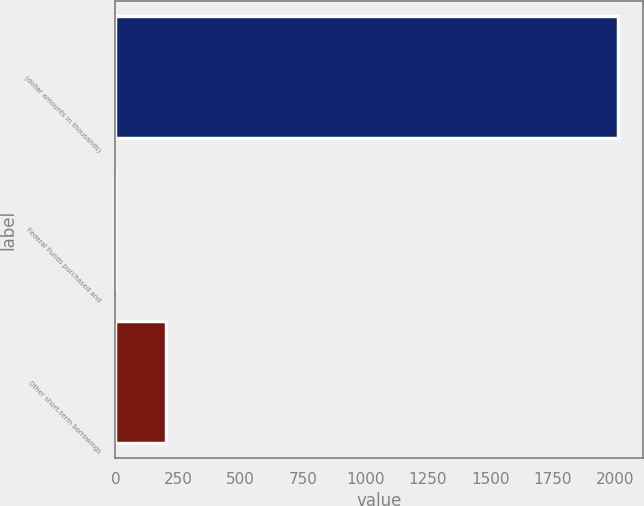<chart> <loc_0><loc_0><loc_500><loc_500><bar_chart><fcel>(dollar amounts in thousands)<fcel>Federal Funds purchased and<fcel>Other short-term borrowings<nl><fcel>2013<fcel>0.06<fcel>201.35<nl></chart> 